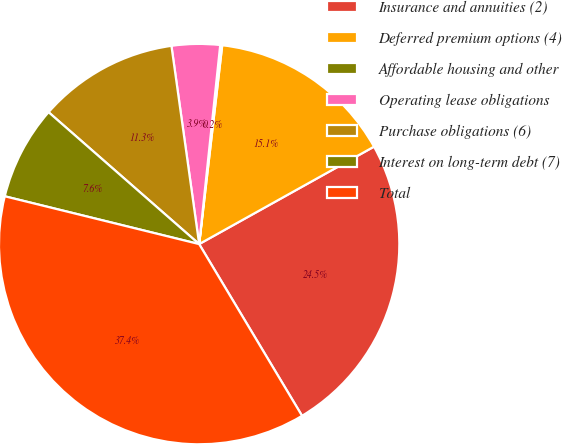Convert chart. <chart><loc_0><loc_0><loc_500><loc_500><pie_chart><fcel>Insurance and annuities (2)<fcel>Deferred premium options (4)<fcel>Affordable housing and other<fcel>Operating lease obligations<fcel>Purchase obligations (6)<fcel>Interest on long-term debt (7)<fcel>Total<nl><fcel>24.5%<fcel>15.07%<fcel>0.16%<fcel>3.89%<fcel>11.34%<fcel>7.61%<fcel>37.43%<nl></chart> 